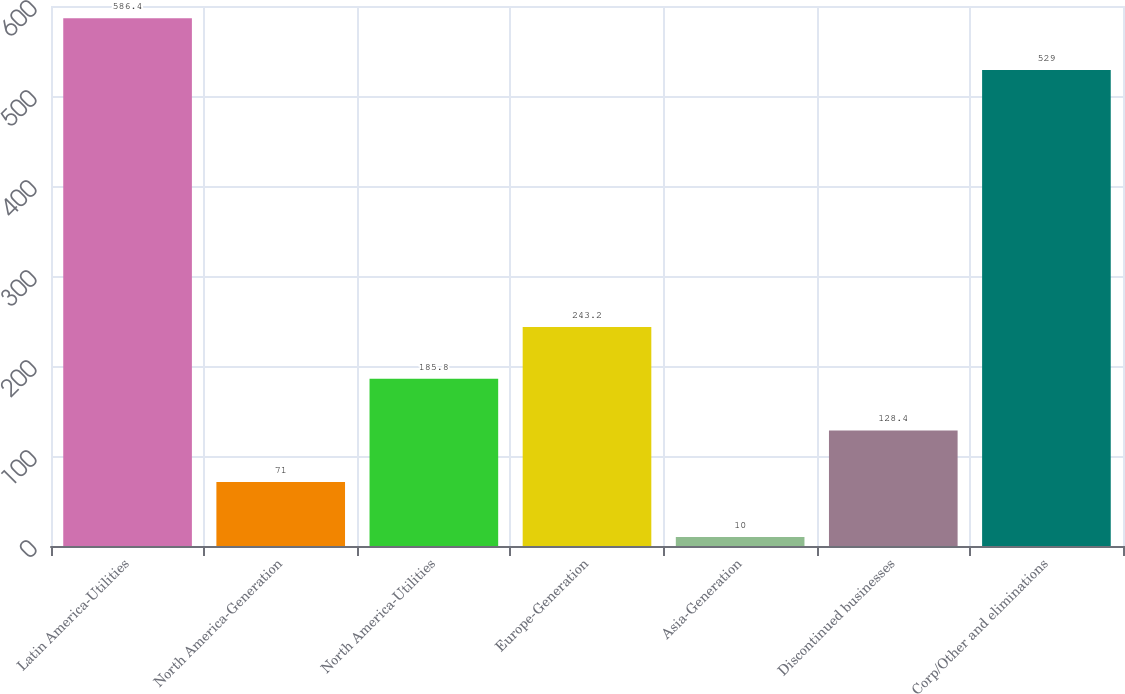<chart> <loc_0><loc_0><loc_500><loc_500><bar_chart><fcel>Latin America-Utilities<fcel>North America-Generation<fcel>North America-Utilities<fcel>Europe-Generation<fcel>Asia-Generation<fcel>Discontinued businesses<fcel>Corp/Other and eliminations<nl><fcel>586.4<fcel>71<fcel>185.8<fcel>243.2<fcel>10<fcel>128.4<fcel>529<nl></chart> 